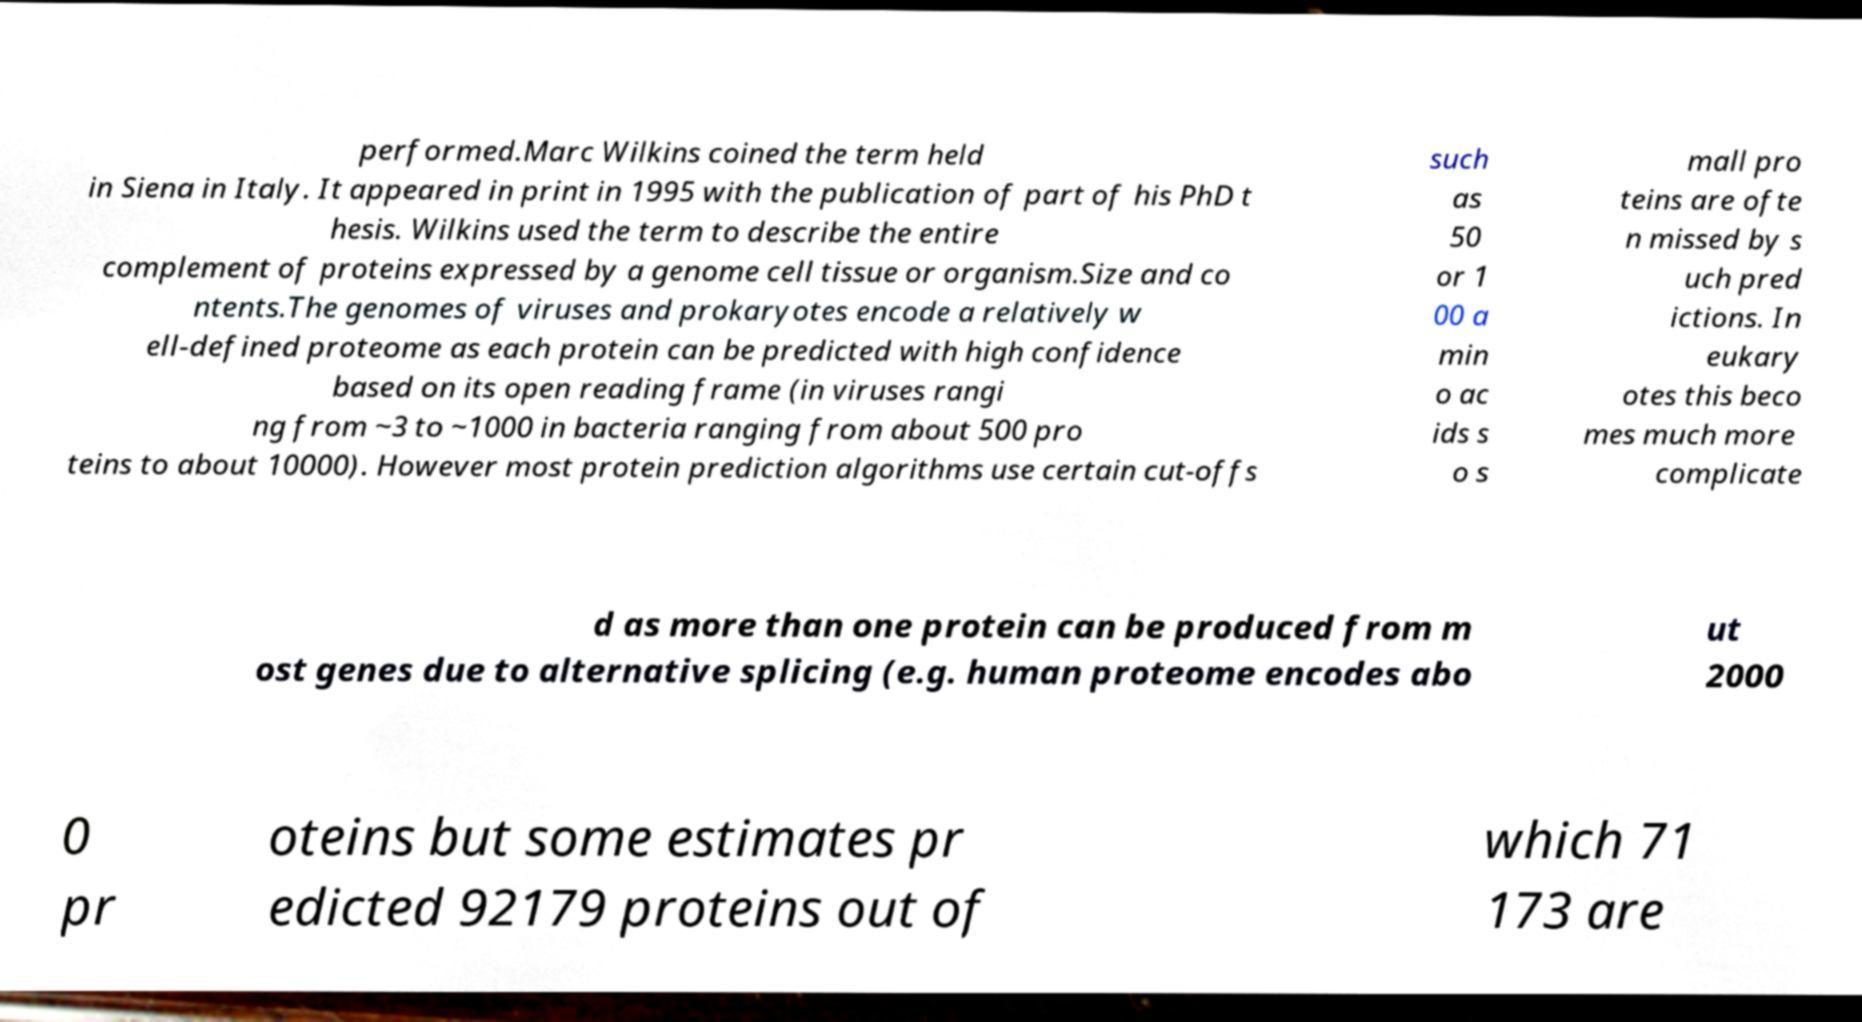Could you extract and type out the text from this image? performed.Marc Wilkins coined the term held in Siena in Italy. It appeared in print in 1995 with the publication of part of his PhD t hesis. Wilkins used the term to describe the entire complement of proteins expressed by a genome cell tissue or organism.Size and co ntents.The genomes of viruses and prokaryotes encode a relatively w ell-defined proteome as each protein can be predicted with high confidence based on its open reading frame (in viruses rangi ng from ~3 to ~1000 in bacteria ranging from about 500 pro teins to about 10000). However most protein prediction algorithms use certain cut-offs such as 50 or 1 00 a min o ac ids s o s mall pro teins are ofte n missed by s uch pred ictions. In eukary otes this beco mes much more complicate d as more than one protein can be produced from m ost genes due to alternative splicing (e.g. human proteome encodes abo ut 2000 0 pr oteins but some estimates pr edicted 92179 proteins out of which 71 173 are 